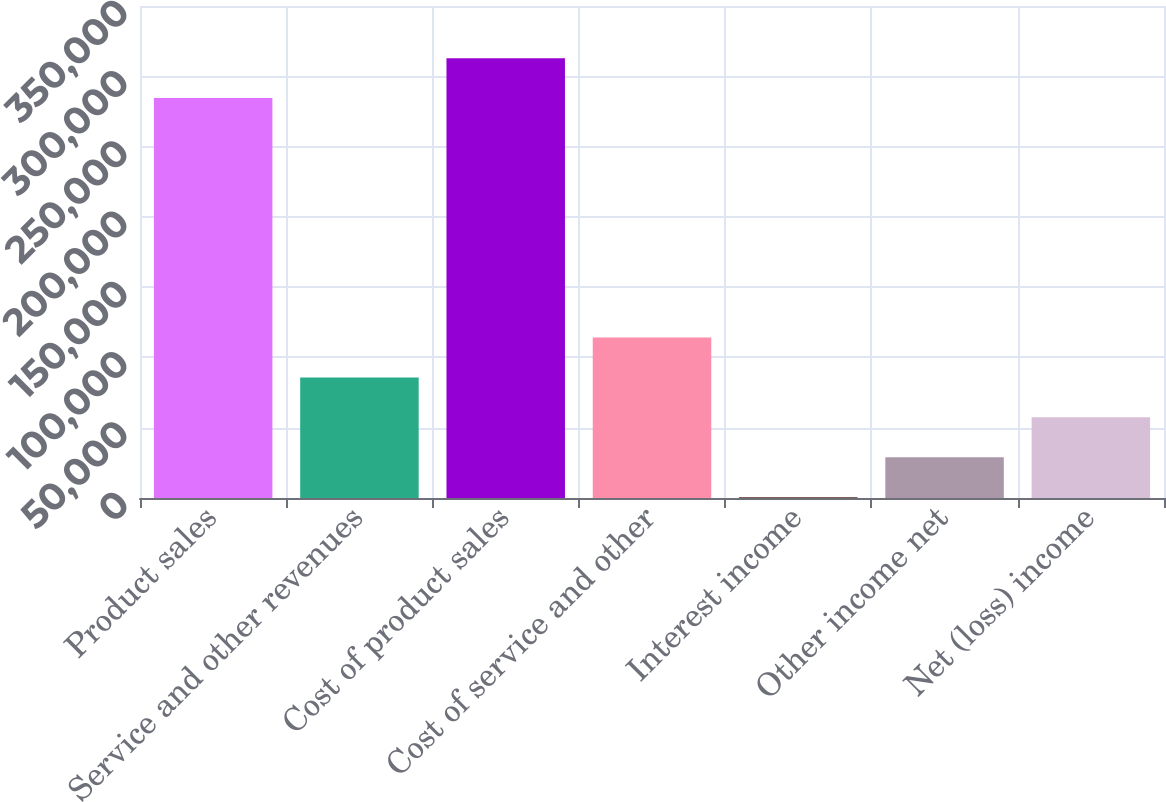Convert chart to OTSL. <chart><loc_0><loc_0><loc_500><loc_500><bar_chart><fcel>Product sales<fcel>Service and other revenues<fcel>Cost of product sales<fcel>Cost of service and other<fcel>Interest income<fcel>Other income net<fcel>Net (loss) income<nl><fcel>284501<fcel>85776.6<fcel>312890<fcel>114166<fcel>609<fcel>28998.2<fcel>57387.4<nl></chart> 